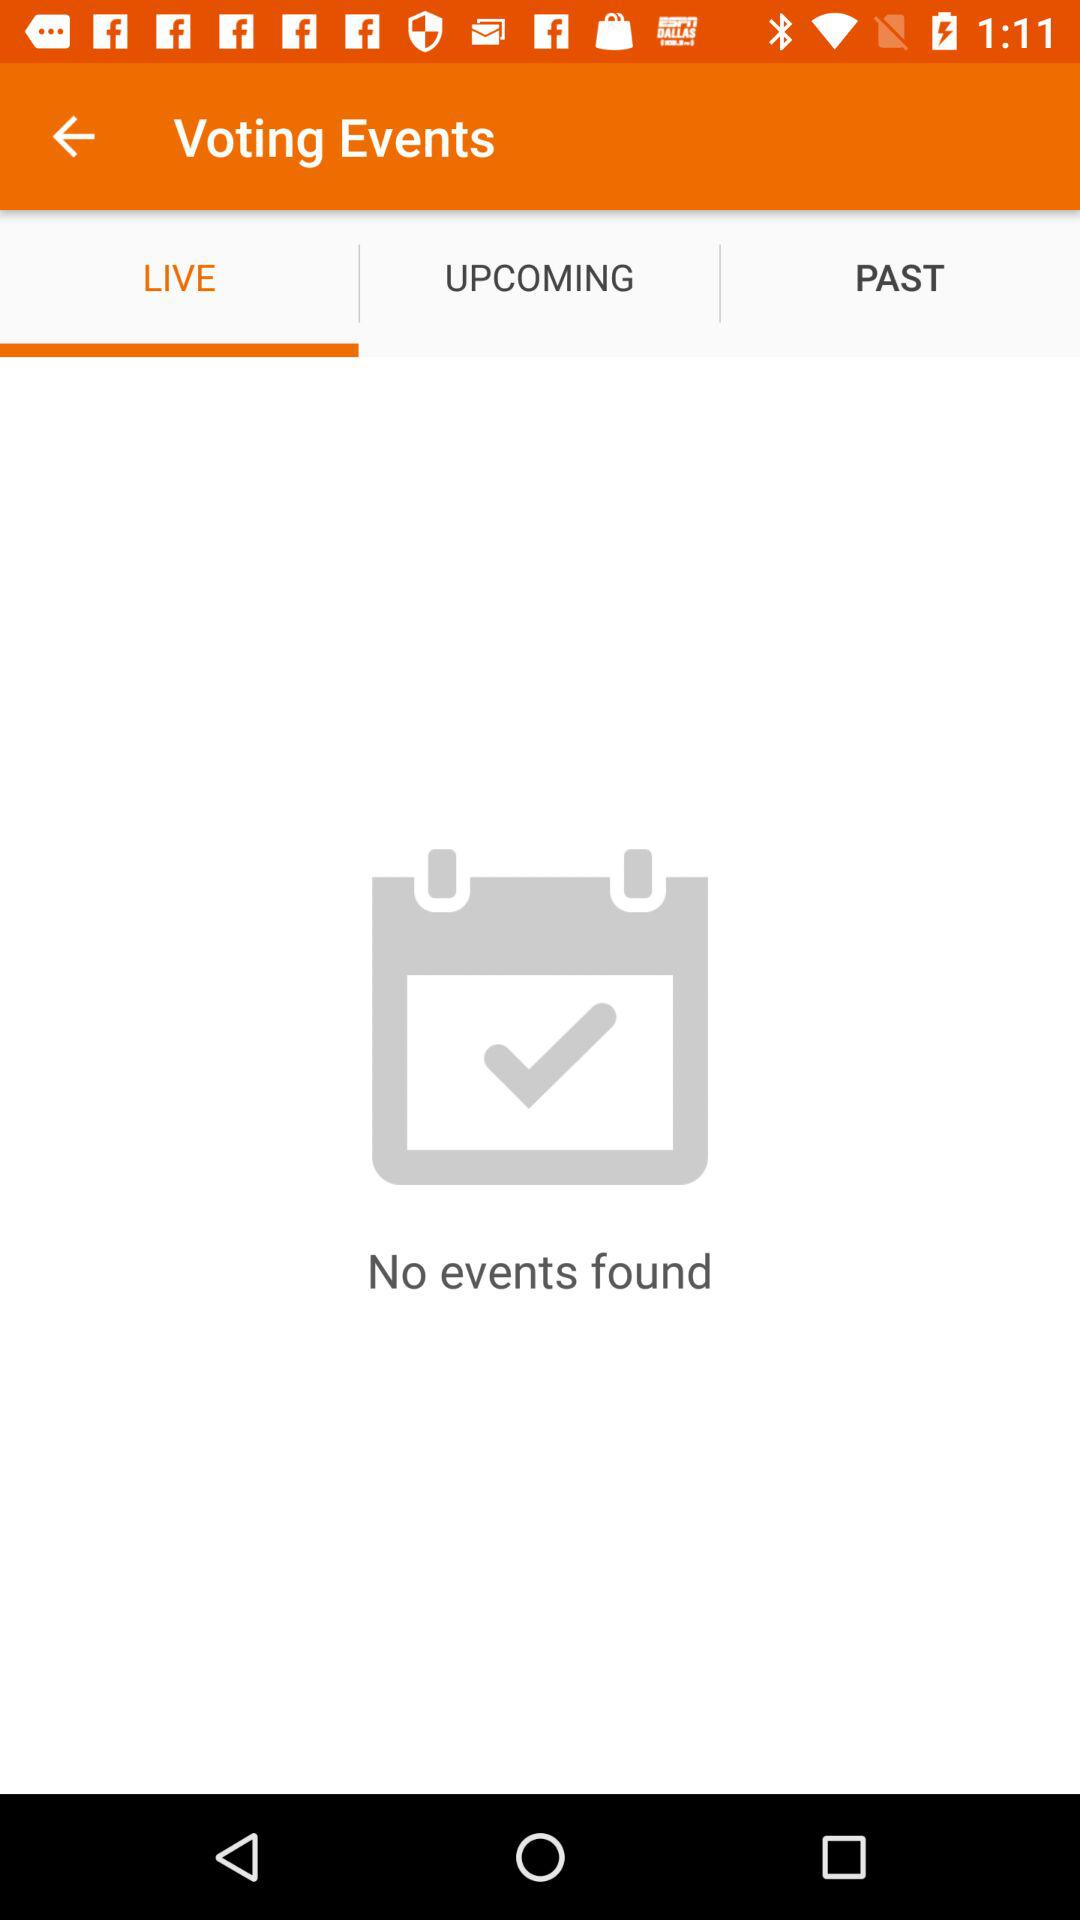How many events are found? There are no events found. 